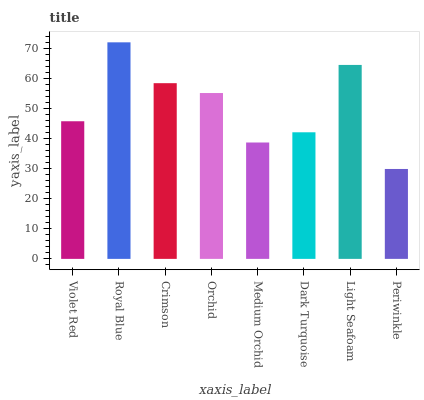Is Periwinkle the minimum?
Answer yes or no. Yes. Is Royal Blue the maximum?
Answer yes or no. Yes. Is Crimson the minimum?
Answer yes or no. No. Is Crimson the maximum?
Answer yes or no. No. Is Royal Blue greater than Crimson?
Answer yes or no. Yes. Is Crimson less than Royal Blue?
Answer yes or no. Yes. Is Crimson greater than Royal Blue?
Answer yes or no. No. Is Royal Blue less than Crimson?
Answer yes or no. No. Is Orchid the high median?
Answer yes or no. Yes. Is Violet Red the low median?
Answer yes or no. Yes. Is Royal Blue the high median?
Answer yes or no. No. Is Light Seafoam the low median?
Answer yes or no. No. 